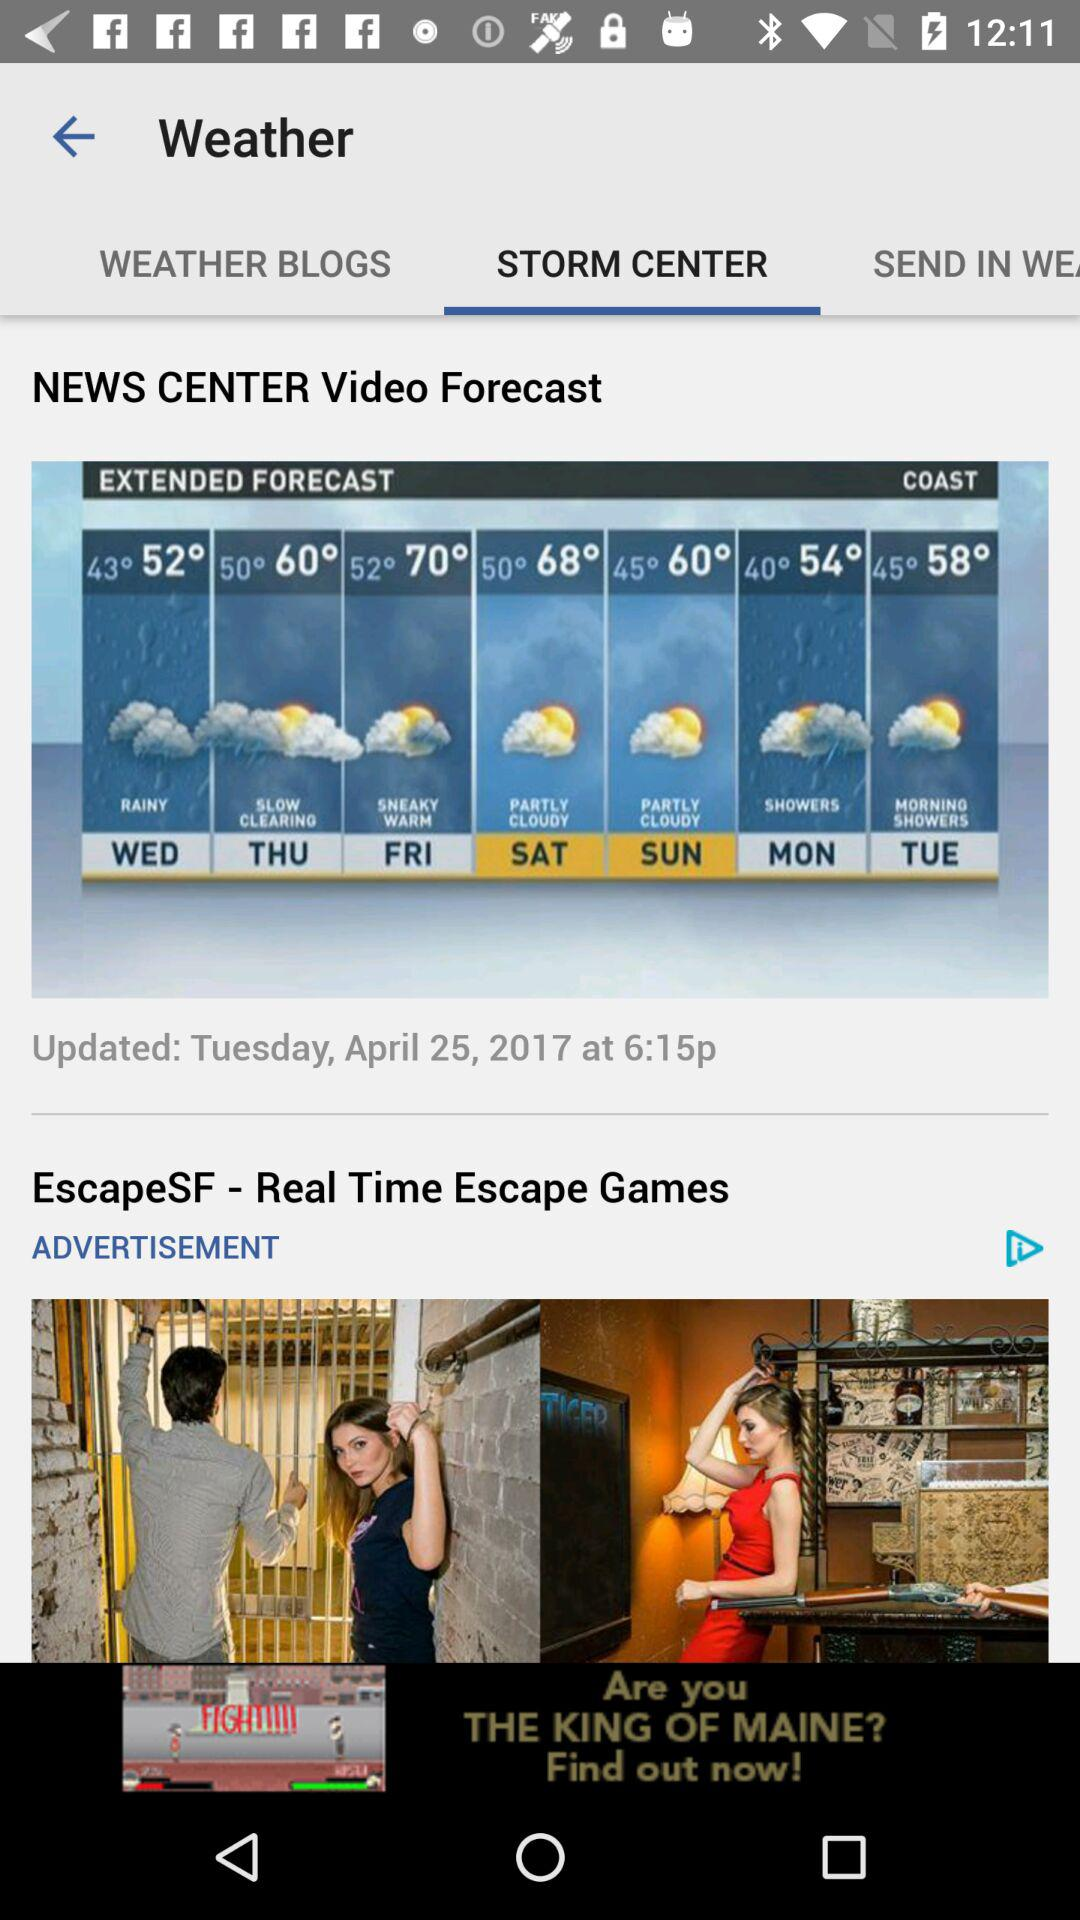When was the forecast updated? The forecast was updated on Tuesday, April 25, 2017 at 6:15 p.m. 